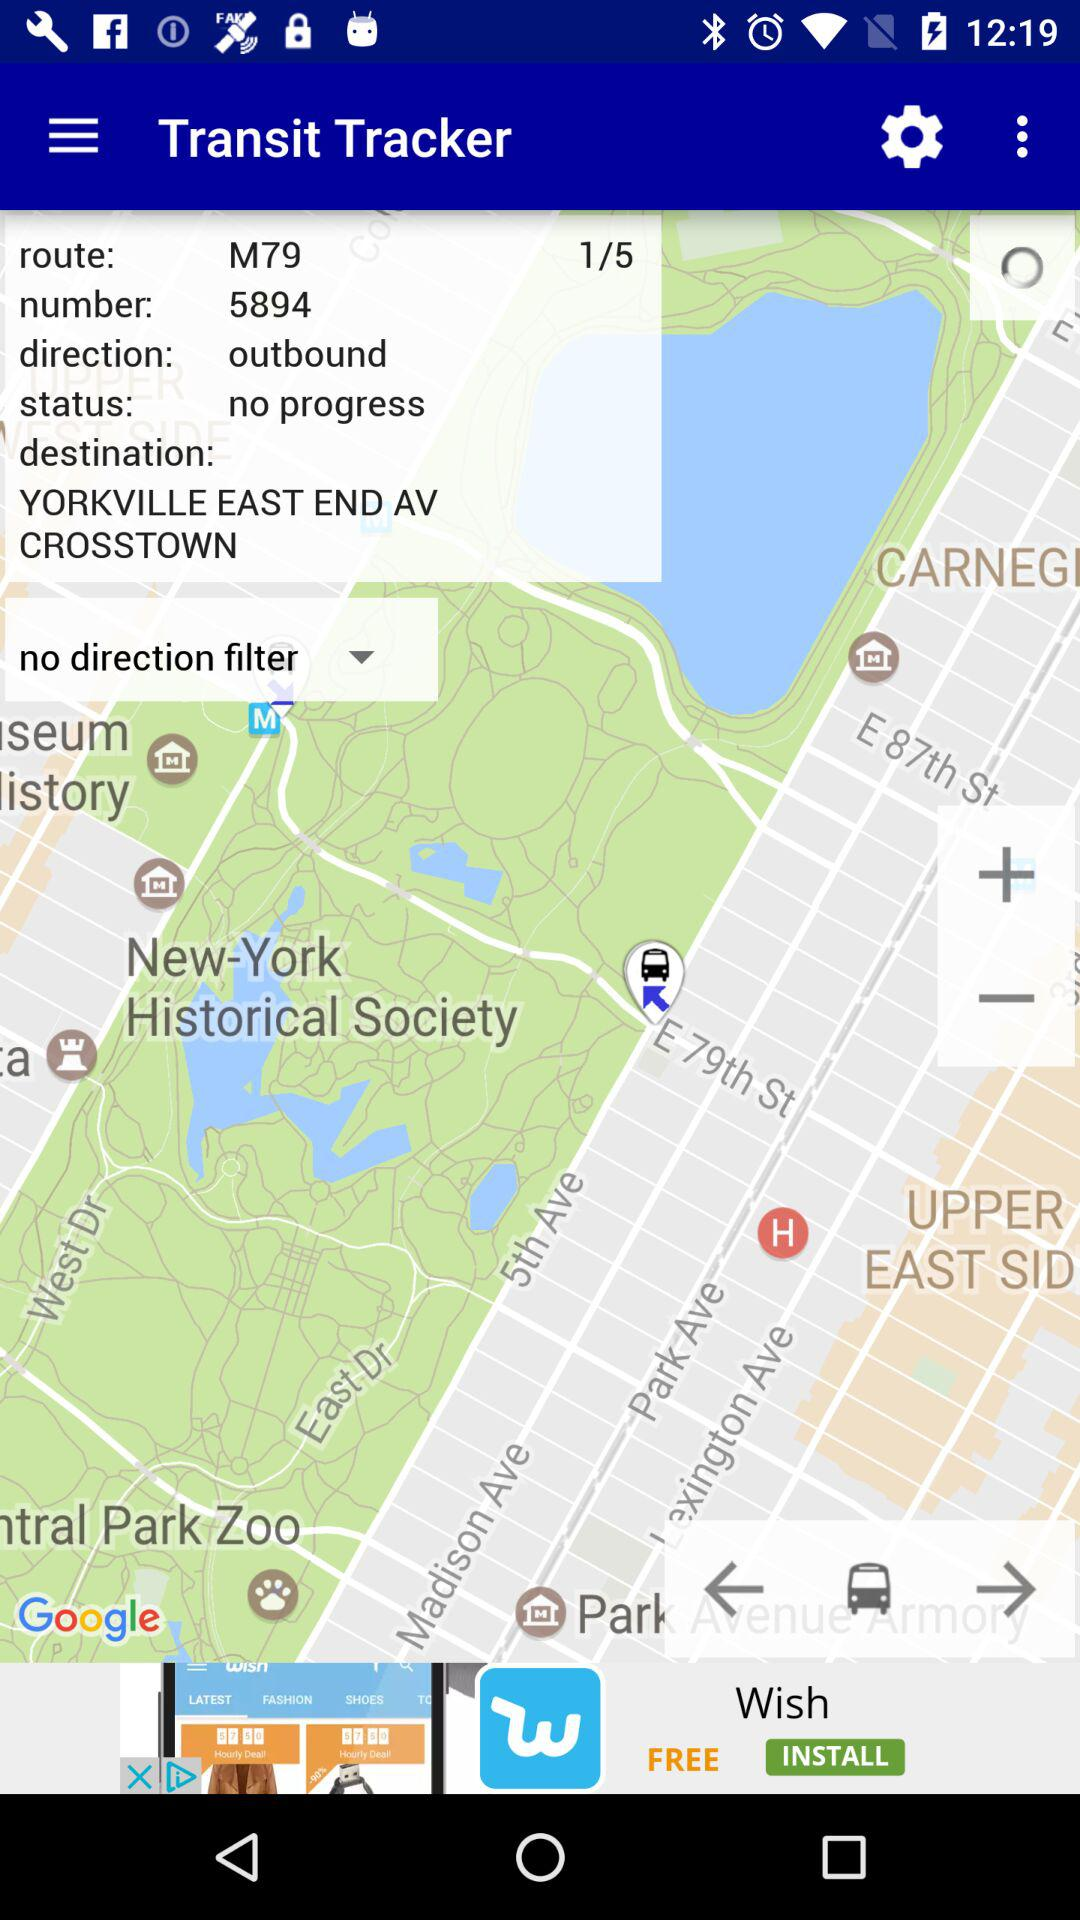What is the total number of stops on the trip?
Answer the question using a single word or phrase. 5 